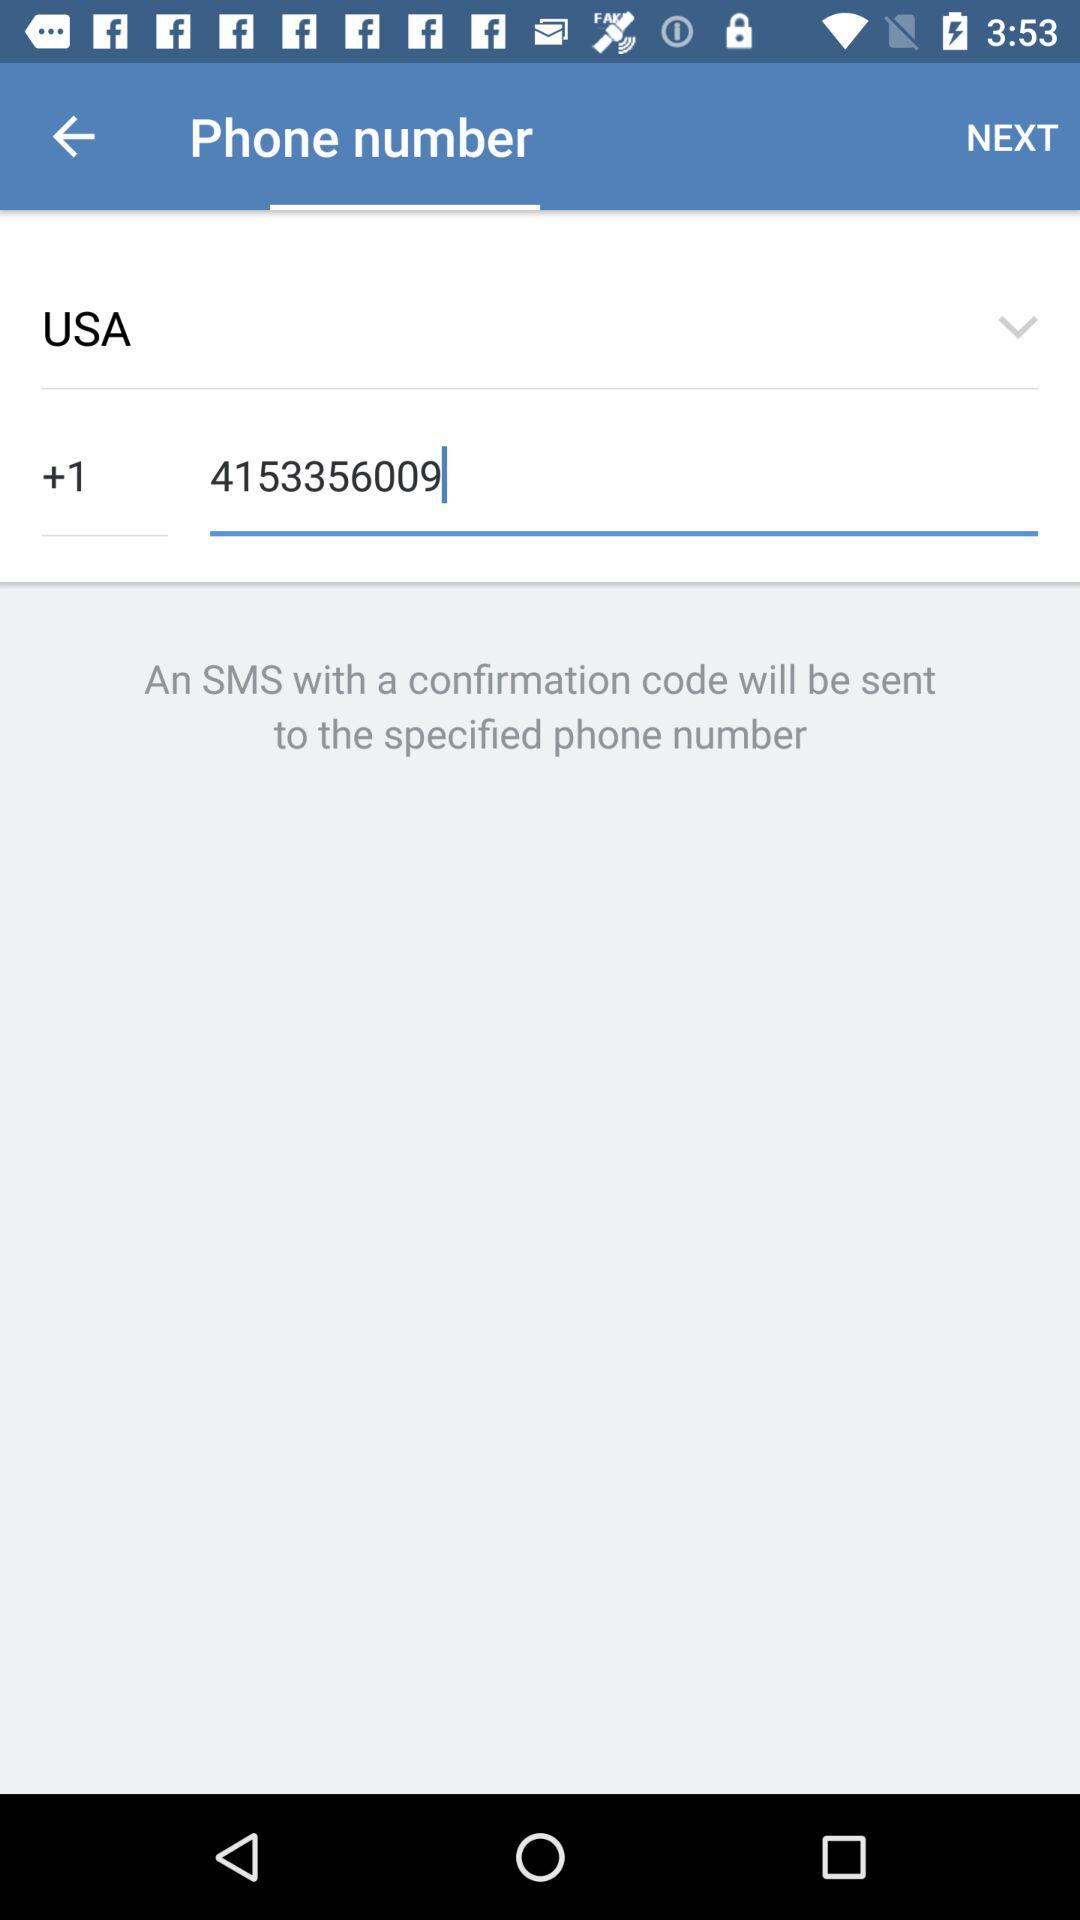What is the selected country? The selected country is USA. 